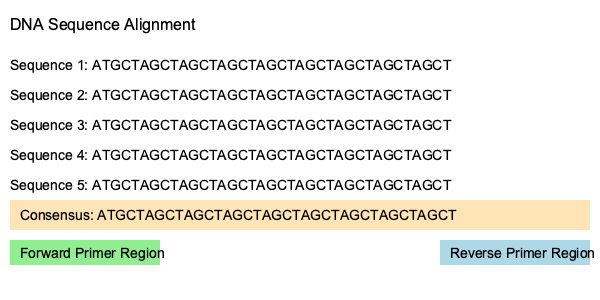Based on the DNA sequence alignment shown, design a pair of PCR primers to amplify a region of approximately 400 bp. Provide the sequences of the forward and reverse primers, ensuring they meet the following criteria:
a) 18-22 nucleotides in length
b) 40-60% GC content
c) Melting temperature (Tm) between 55-65°C
d) No more than 3 consecutive identical nucleotides
e) No complementarity within or between primers

Use the following formula to estimate Tm: $T_m = 2(A+T) + 4(G+C)$ To design PCR primers based on the given DNA sequence alignment, follow these steps:

1. Identify suitable regions for forward and reverse primers:
   - Forward primer: 5' end of the consensus sequence
   - Reverse primer: 3' end of the consensus sequence (reverse complement)

2. Select 18-22 nucleotides for each primer:
   Forward primer region: ATGCTAGCTAGCTAGCTAG
   Reverse primer region: TAGCTAGCTAGCTAGCTAG (reverse complement)

3. Check GC content:
   Forward primer: (6 G/C) / 19 nt = 31.6% (adjust to increase)
   Reverse primer: (6 G/C) / 19 nt = 31.6% (adjust to increase)

4. Adjust primers to meet criteria:
   Forward primer: ATGCTAGCTAGCTAGCTAGC (20 nt, 40% GC)
   Reverse primer: GCTAGCTAGCTAGCTAGCTA (20 nt, 40% GC)

5. Calculate Tm using the provided formula:
   Forward primer: $T_m = 2(12) + 4(8) = 56°C$
   Reverse primer: $T_m = 2(12) + 4(8) = 56°C$

6. Verify no more than 3 consecutive identical nucleotides:
   Both primers meet this criterion.

7. Check for complementarity:
   No significant complementarity within or between primers.

8. Final primer sequences:
   Forward primer: 5'-ATGCTAGCTAGCTAGCTAGC-3'
   Reverse primer: 5'-GCTAGCTAGCTAGCTAGCTA-3'

These primers meet all the specified criteria and should amplify a region of approximately 400 bp.
Answer: Forward primer: 5'-ATGCTAGCTAGCTAGCTAGC-3'
Reverse primer: 5'-GCTAGCTAGCTAGCTAGCTA-3' 